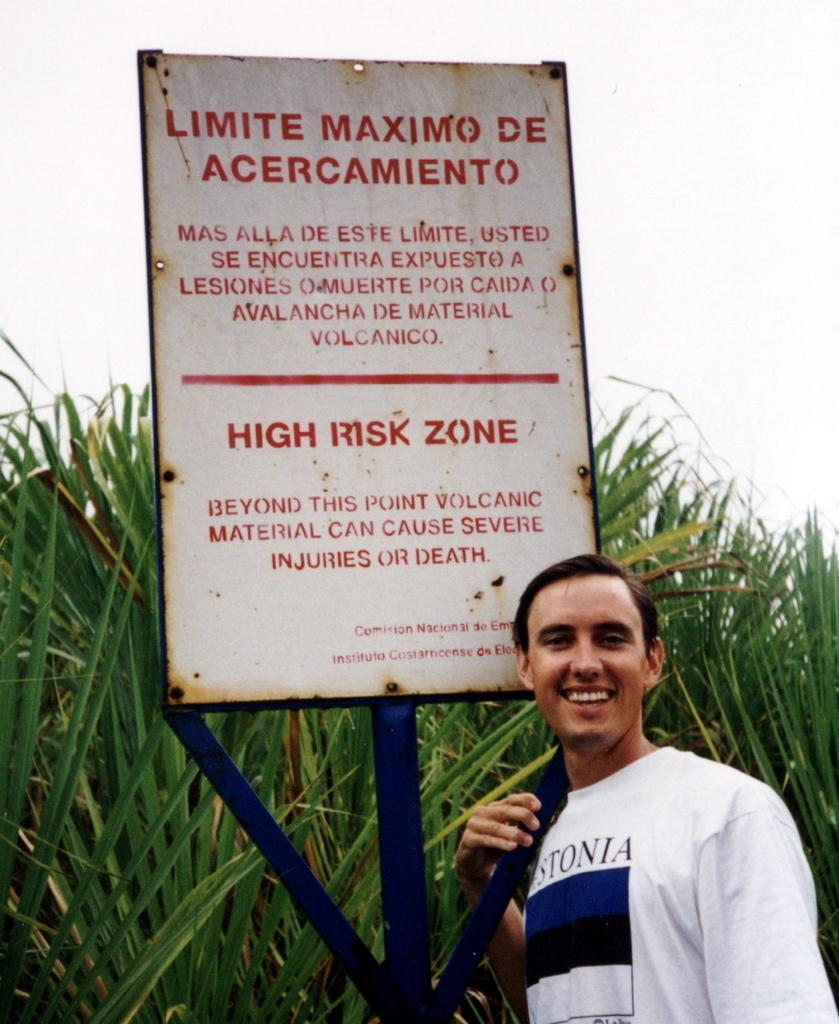<image>
Render a clear and concise summary of the photo. A man is posing with a High Risk Zone sign. 